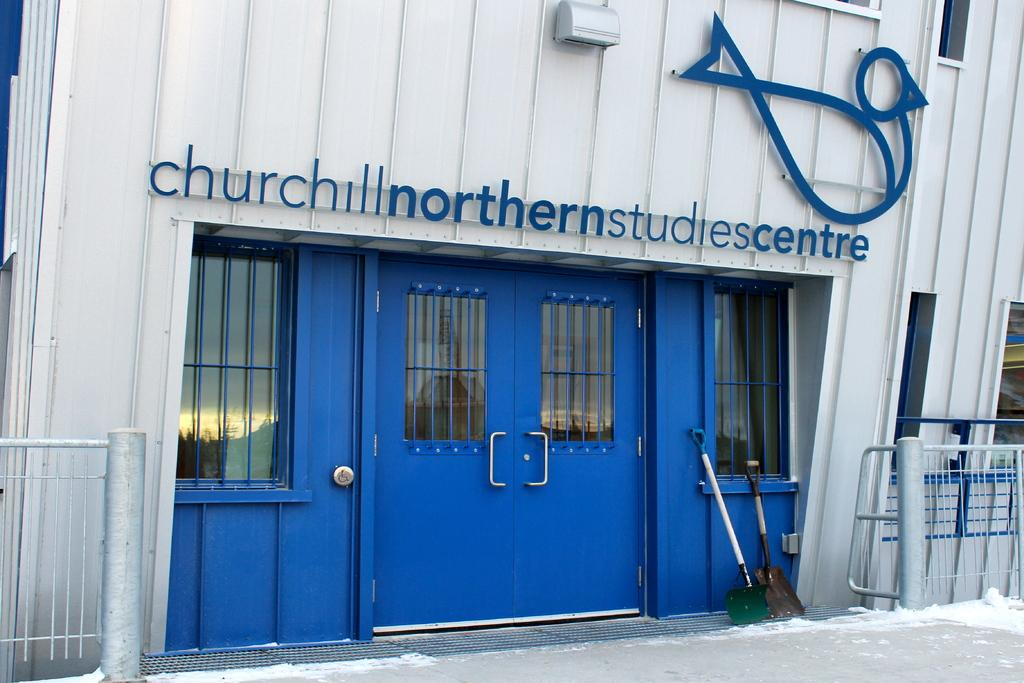<image>
Render a clear and concise summary of the photo. The front of the Churchill Northern Studies Centre has blue doors on the building. 